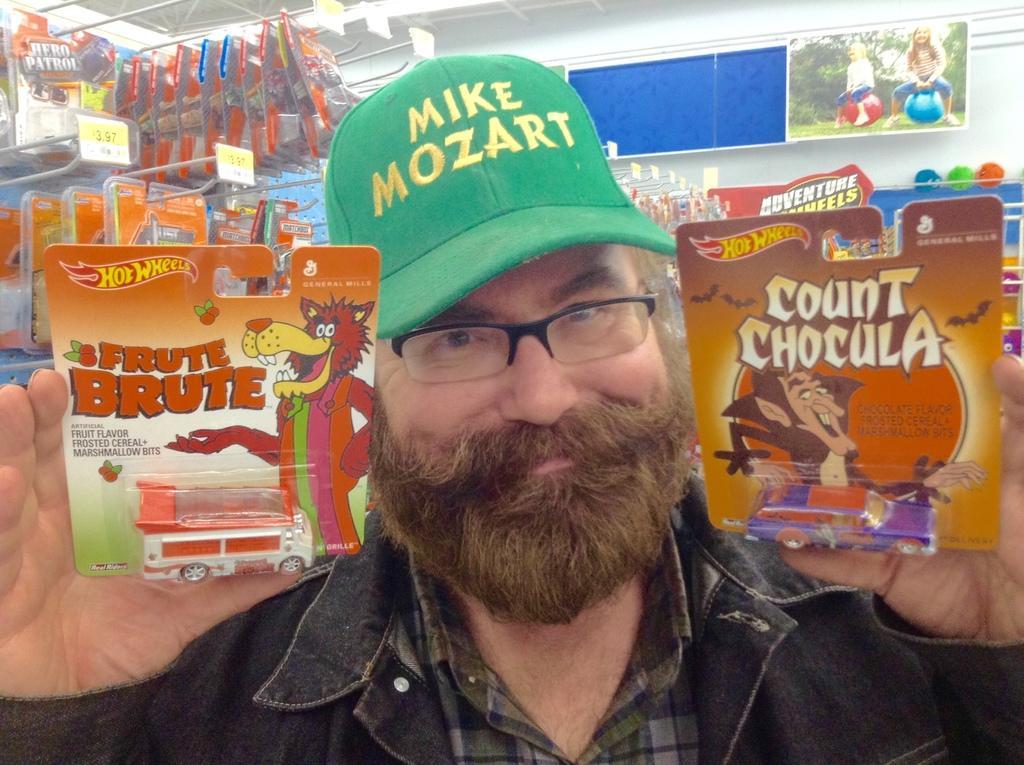Please provide a concise description of this image. In this image I can see a person is wearing gray color jacket and holding two cardboard sheets. Background I can see a board in blue color attached to the wall, few toys hanged to the pole and the wall is in white color. 